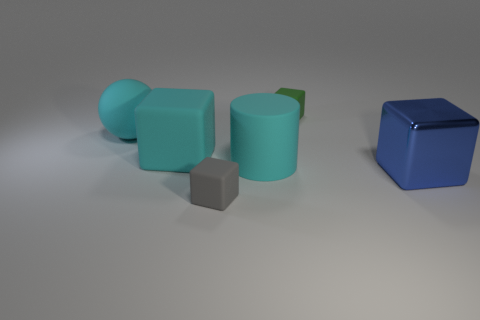Subtract all cyan cubes. How many cubes are left? 3 Subtract all red cubes. Subtract all yellow spheres. How many cubes are left? 4 Add 1 large brown objects. How many objects exist? 7 Subtract all blocks. How many objects are left? 2 Subtract 0 brown cylinders. How many objects are left? 6 Subtract all rubber cubes. Subtract all large rubber spheres. How many objects are left? 2 Add 5 big cyan objects. How many big cyan objects are left? 8 Add 4 brown rubber cylinders. How many brown rubber cylinders exist? 4 